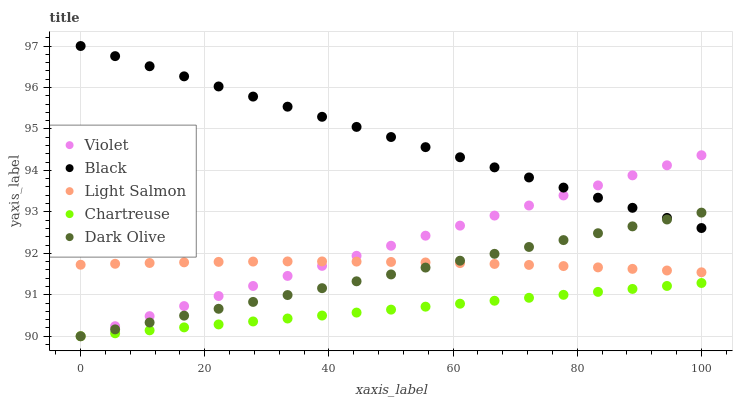Does Chartreuse have the minimum area under the curve?
Answer yes or no. Yes. Does Black have the maximum area under the curve?
Answer yes or no. Yes. Does Dark Olive have the minimum area under the curve?
Answer yes or no. No. Does Dark Olive have the maximum area under the curve?
Answer yes or no. No. Is Chartreuse the smoothest?
Answer yes or no. Yes. Is Light Salmon the roughest?
Answer yes or no. Yes. Is Dark Olive the smoothest?
Answer yes or no. No. Is Dark Olive the roughest?
Answer yes or no. No. Does Dark Olive have the lowest value?
Answer yes or no. Yes. Does Black have the lowest value?
Answer yes or no. No. Does Black have the highest value?
Answer yes or no. Yes. Does Dark Olive have the highest value?
Answer yes or no. No. Is Light Salmon less than Black?
Answer yes or no. Yes. Is Black greater than Chartreuse?
Answer yes or no. Yes. Does Chartreuse intersect Dark Olive?
Answer yes or no. Yes. Is Chartreuse less than Dark Olive?
Answer yes or no. No. Is Chartreuse greater than Dark Olive?
Answer yes or no. No. Does Light Salmon intersect Black?
Answer yes or no. No. 